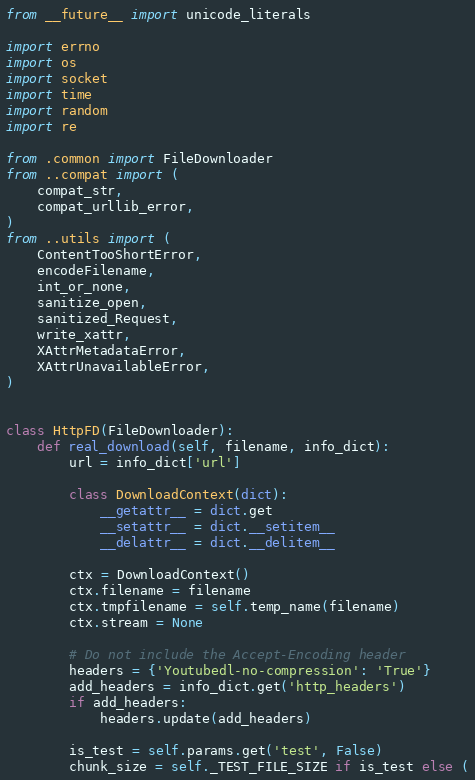<code> <loc_0><loc_0><loc_500><loc_500><_Python_>from __future__ import unicode_literals

import errno
import os
import socket
import time
import random
import re

from .common import FileDownloader
from ..compat import (
    compat_str,
    compat_urllib_error,
)
from ..utils import (
    ContentTooShortError,
    encodeFilename,
    int_or_none,
    sanitize_open,
    sanitized_Request,
    write_xattr,
    XAttrMetadataError,
    XAttrUnavailableError,
)


class HttpFD(FileDownloader):
    def real_download(self, filename, info_dict):
        url = info_dict['url']

        class DownloadContext(dict):
            __getattr__ = dict.get
            __setattr__ = dict.__setitem__
            __delattr__ = dict.__delitem__

        ctx = DownloadContext()
        ctx.filename = filename
        ctx.tmpfilename = self.temp_name(filename)
        ctx.stream = None

        # Do not include the Accept-Encoding header
        headers = {'Youtubedl-no-compression': 'True'}
        add_headers = info_dict.get('http_headers')
        if add_headers:
            headers.update(add_headers)

        is_test = self.params.get('test', False)
        chunk_size = self._TEST_FILE_SIZE if is_test else (</code> 